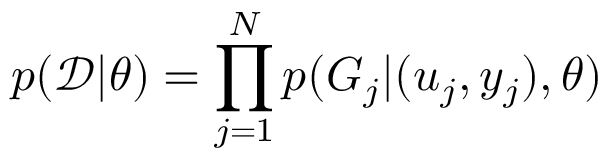<formula> <loc_0><loc_0><loc_500><loc_500>p ( \mathcal { D } | \theta ) = \prod _ { j = 1 } ^ { N } p ( G _ { j } | ( u _ { j } , y _ { j } ) , \theta )</formula> 